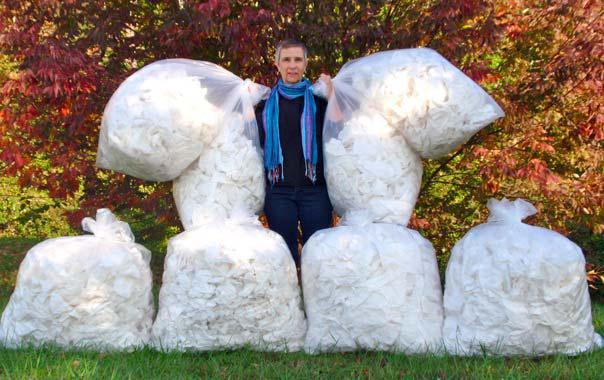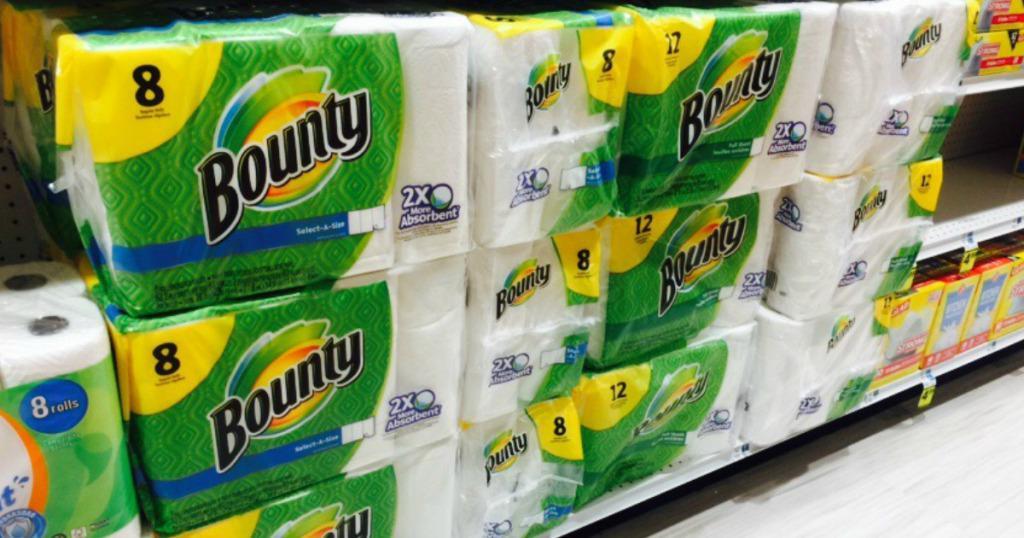The first image is the image on the left, the second image is the image on the right. Given the left and right images, does the statement "The left-hand image shows exactly one multi-pack of paper towels." hold true? Answer yes or no. No. The first image is the image on the left, the second image is the image on the right. Evaluate the accuracy of this statement regarding the images: "A single package of paper towels stands alone in the image on the left.". Is it true? Answer yes or no. No. 